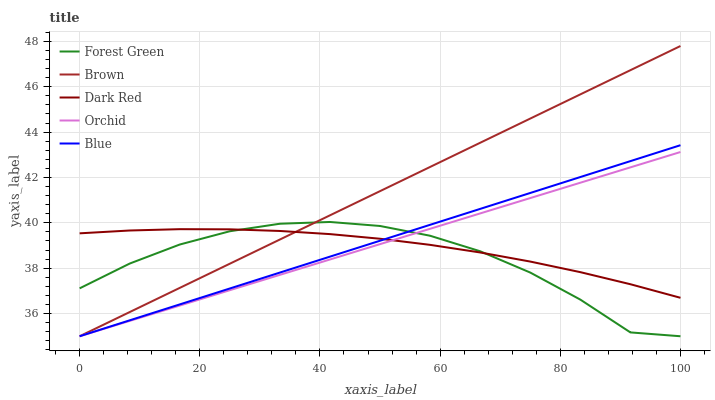Does Forest Green have the minimum area under the curve?
Answer yes or no. Yes. Does Brown have the maximum area under the curve?
Answer yes or no. Yes. Does Brown have the minimum area under the curve?
Answer yes or no. No. Does Forest Green have the maximum area under the curve?
Answer yes or no. No. Is Blue the smoothest?
Answer yes or no. Yes. Is Forest Green the roughest?
Answer yes or no. Yes. Is Brown the smoothest?
Answer yes or no. No. Is Brown the roughest?
Answer yes or no. No. Does Blue have the lowest value?
Answer yes or no. Yes. Does Dark Red have the lowest value?
Answer yes or no. No. Does Brown have the highest value?
Answer yes or no. Yes. Does Forest Green have the highest value?
Answer yes or no. No. Does Brown intersect Orchid?
Answer yes or no. Yes. Is Brown less than Orchid?
Answer yes or no. No. Is Brown greater than Orchid?
Answer yes or no. No. 